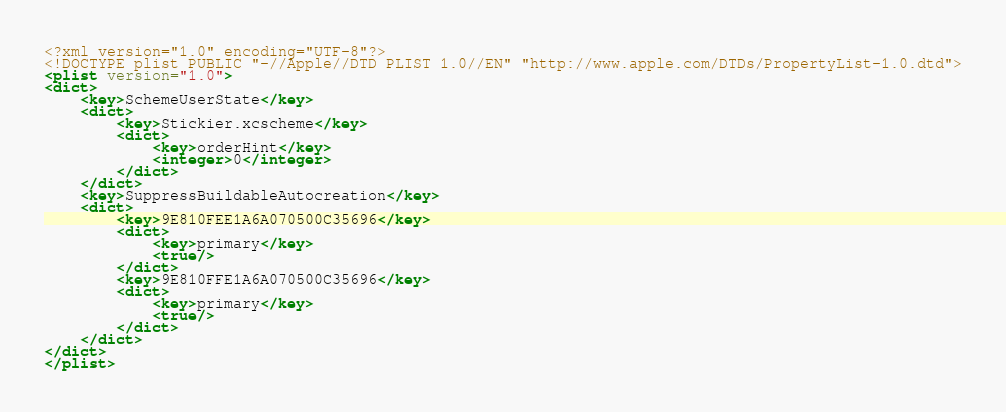Convert code to text. <code><loc_0><loc_0><loc_500><loc_500><_XML_><?xml version="1.0" encoding="UTF-8"?>
<!DOCTYPE plist PUBLIC "-//Apple//DTD PLIST 1.0//EN" "http://www.apple.com/DTDs/PropertyList-1.0.dtd">
<plist version="1.0">
<dict>
	<key>SchemeUserState</key>
	<dict>
		<key>Stickier.xcscheme</key>
		<dict>
			<key>orderHint</key>
			<integer>0</integer>
		</dict>
	</dict>
	<key>SuppressBuildableAutocreation</key>
	<dict>
		<key>9E810FEE1A6A070500C35696</key>
		<dict>
			<key>primary</key>
			<true/>
		</dict>
		<key>9E810FFE1A6A070500C35696</key>
		<dict>
			<key>primary</key>
			<true/>
		</dict>
	</dict>
</dict>
</plist>
</code> 